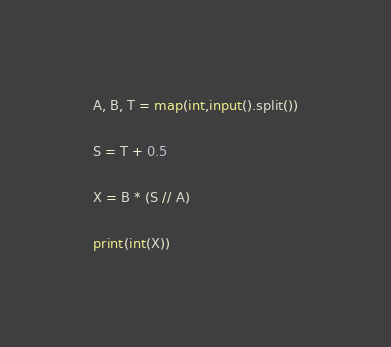Convert code to text. <code><loc_0><loc_0><loc_500><loc_500><_Python_>A, B, T = map(int,input().split())

S = T + 0.5

X = B * (S // A)

print(int(X))

</code> 